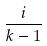Convert formula to latex. <formula><loc_0><loc_0><loc_500><loc_500>\frac { i } { k - 1 }</formula> 